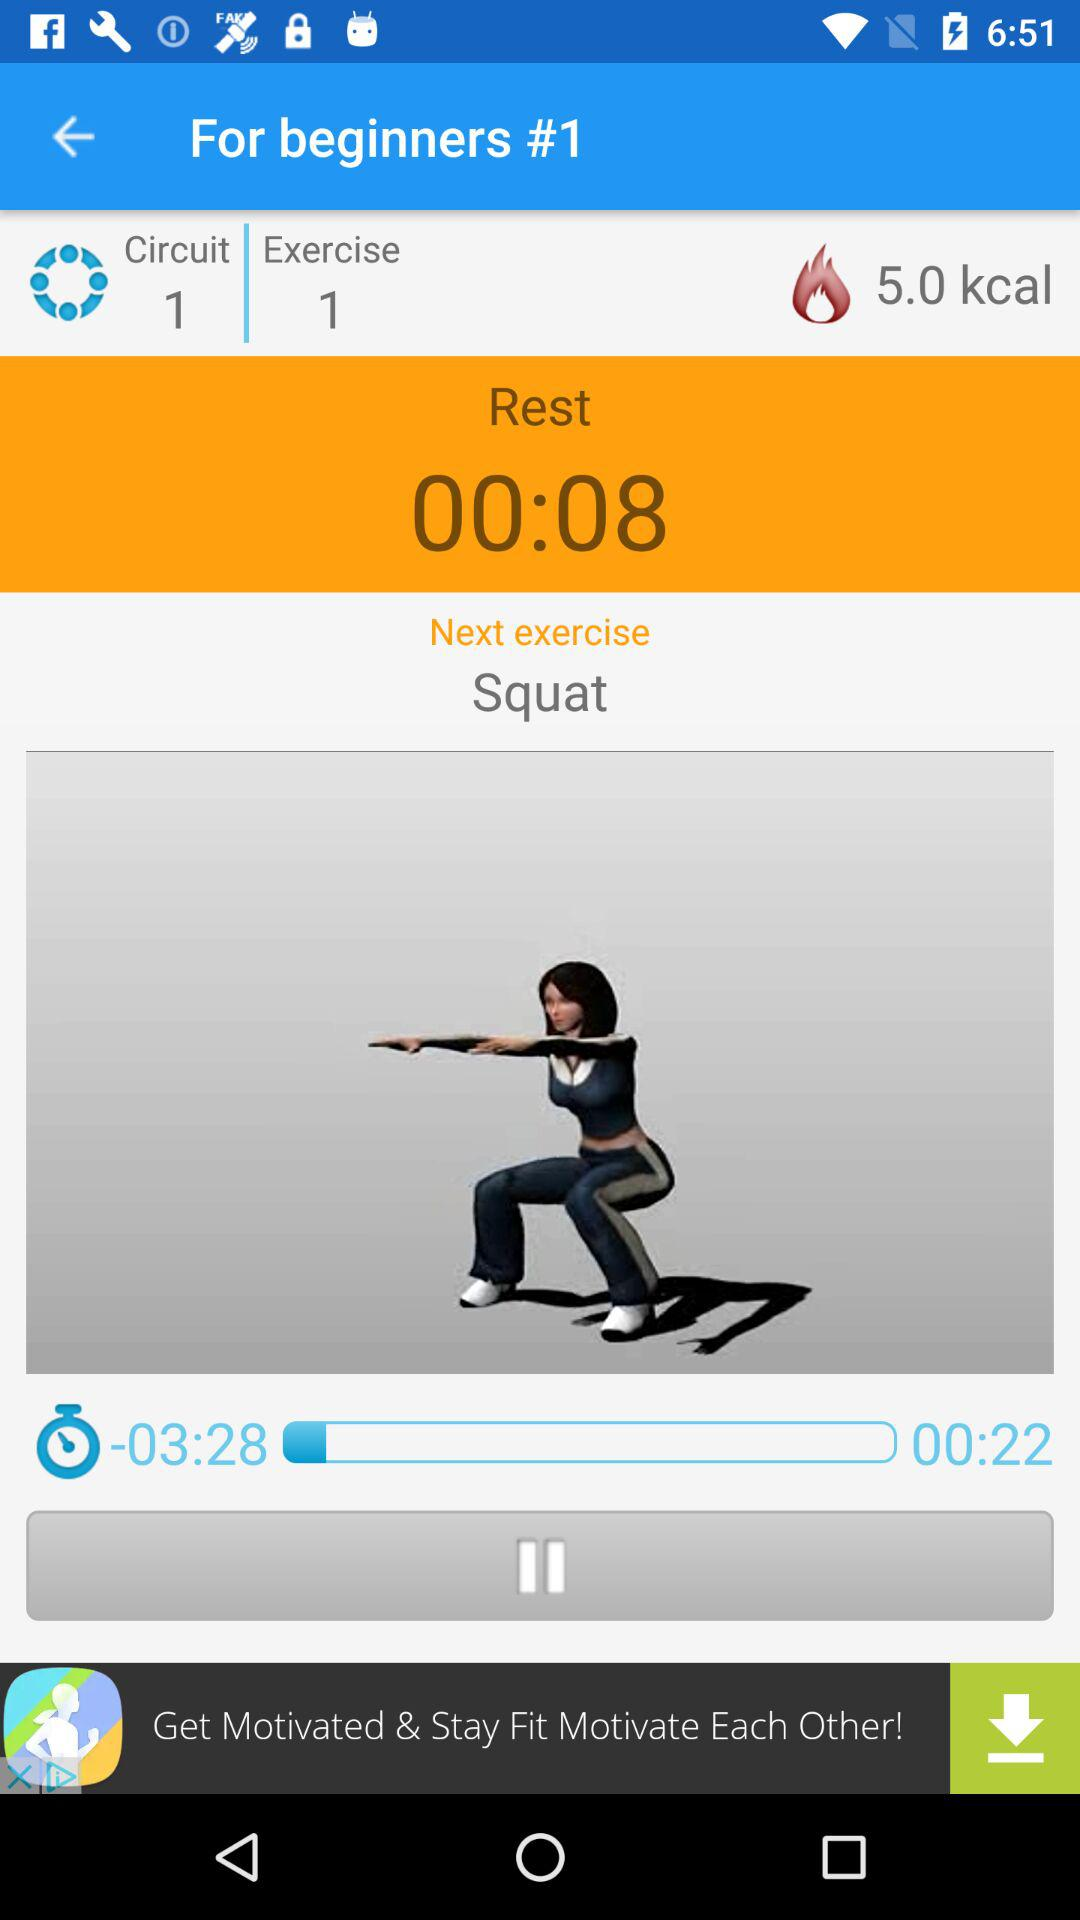How many calories are shown there? There are 5 calories. 